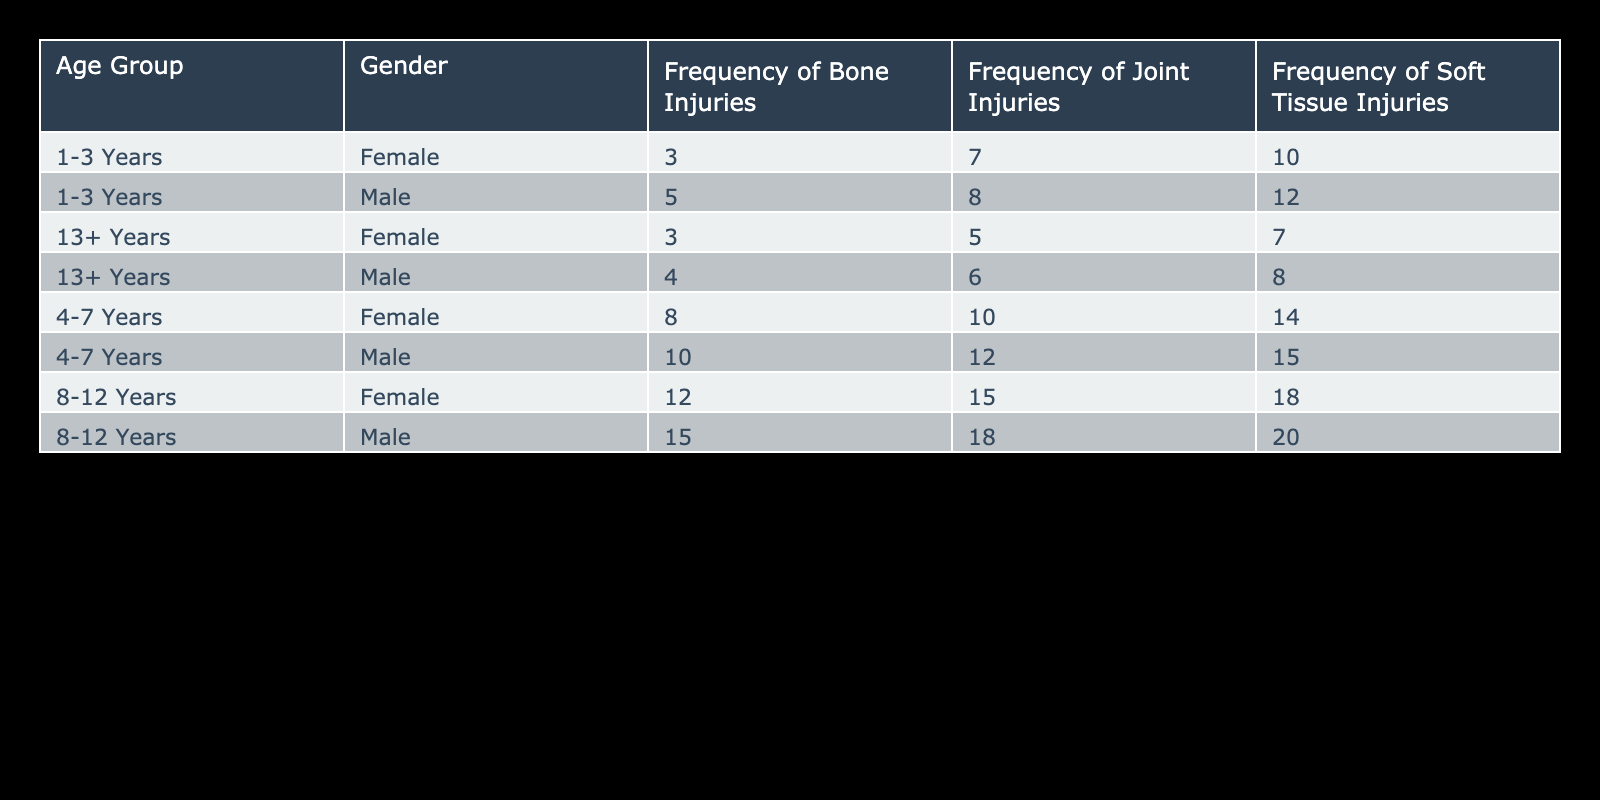What's the frequency of soft tissue injuries for female horses aged 4-7 years? From the table, under the "4-7 Years" age group and "Female" gender, the frequency of soft tissue injuries is directly stated as 14.
Answer: 14 What is the total frequency of joint injuries for male horses across all age groups? The total frequency of joint injuries for male horses can be calculated by summing the values from each age group: 8 (1-3 Years) + 12 (4-7 Years) + 18 (8-12 Years) + 6 (13+ Years) = 44.
Answer: 44 Are there more bone injuries in male or female horses aged 8-12 years? For the age group "8-12 Years," the frequency of bone injuries is 15 for males and 12 for females. Thus, males have more bone injuries in this age group.
Answer: Yes What is the difference in frequency of soft tissue injuries between male and female horses aged 1-3 years? The frequency of soft tissue injuries for males is 12, while for females, it is 10. The difference is 12 - 10 = 2.
Answer: 2 What is the average frequency of bone injuries for all age groups combined, across both genders? To find the average, sum the total frequencies of bone injuries for all age groups and genders: 5 (male 1-3) + 3 (female 1-3) + 10 (male 4-7) + 8 (female 4-7) + 15 (male 8-12) + 12 (female 8-12) + 4 (male 13+) + 3 (female 13+) = 66. There are 8 data points (4 age groups and 2 genders), so the average is 66/8 = 8.25.
Answer: 8.25 Which gender has a higher frequency of injuries in the 13+ years age group? For the age group "13+ Years," the frequency of injuries for males is 4 (bone) + 6 (joint) + 8 (soft tissue) = 18. For females, it is 3 (bone) + 5 (joint) + 7 (soft tissue) = 15. Males have a higher total frequency of injuries in this age group.
Answer: Male What's the frequency of soft tissue injuries for horses aged 8-12 years, and does it exceed the frequency of joint injuries for the same age range? For horses aged "8-12 Years," the frequency of soft tissue injuries is 20 (males) + 18 (females) = 38, while the frequency of joint injuries is 18 (males) + 15 (females) = 33. Since 38 exceeds 33, it confirms that the soft tissue injuries frequency is higher.
Answer: Yes 